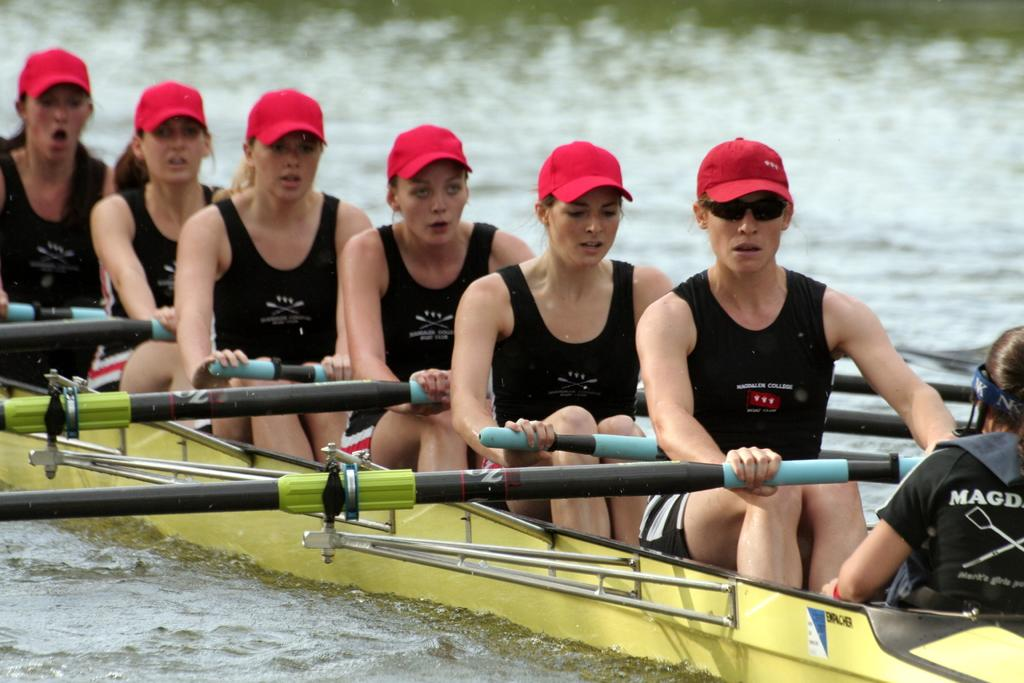What is happening in the image? There is a group of people in the image, and they are sitting in a boat. Where is the boat located? The boat is on the water. What are the people wearing? The people are wearing black-colored dresses. What are the people holding in their hands? The people are holding sticks. What type of cable can be seen connecting the people in the image? There is no cable present in the image; the people are holding sticks. 